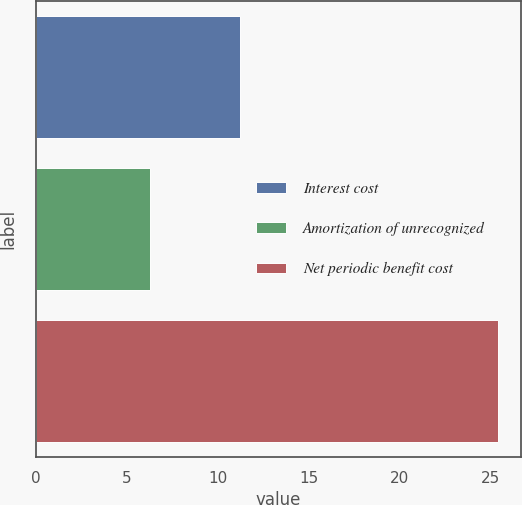Convert chart to OTSL. <chart><loc_0><loc_0><loc_500><loc_500><bar_chart><fcel>Interest cost<fcel>Amortization of unrecognized<fcel>Net periodic benefit cost<nl><fcel>11.2<fcel>6.3<fcel>25.4<nl></chart> 